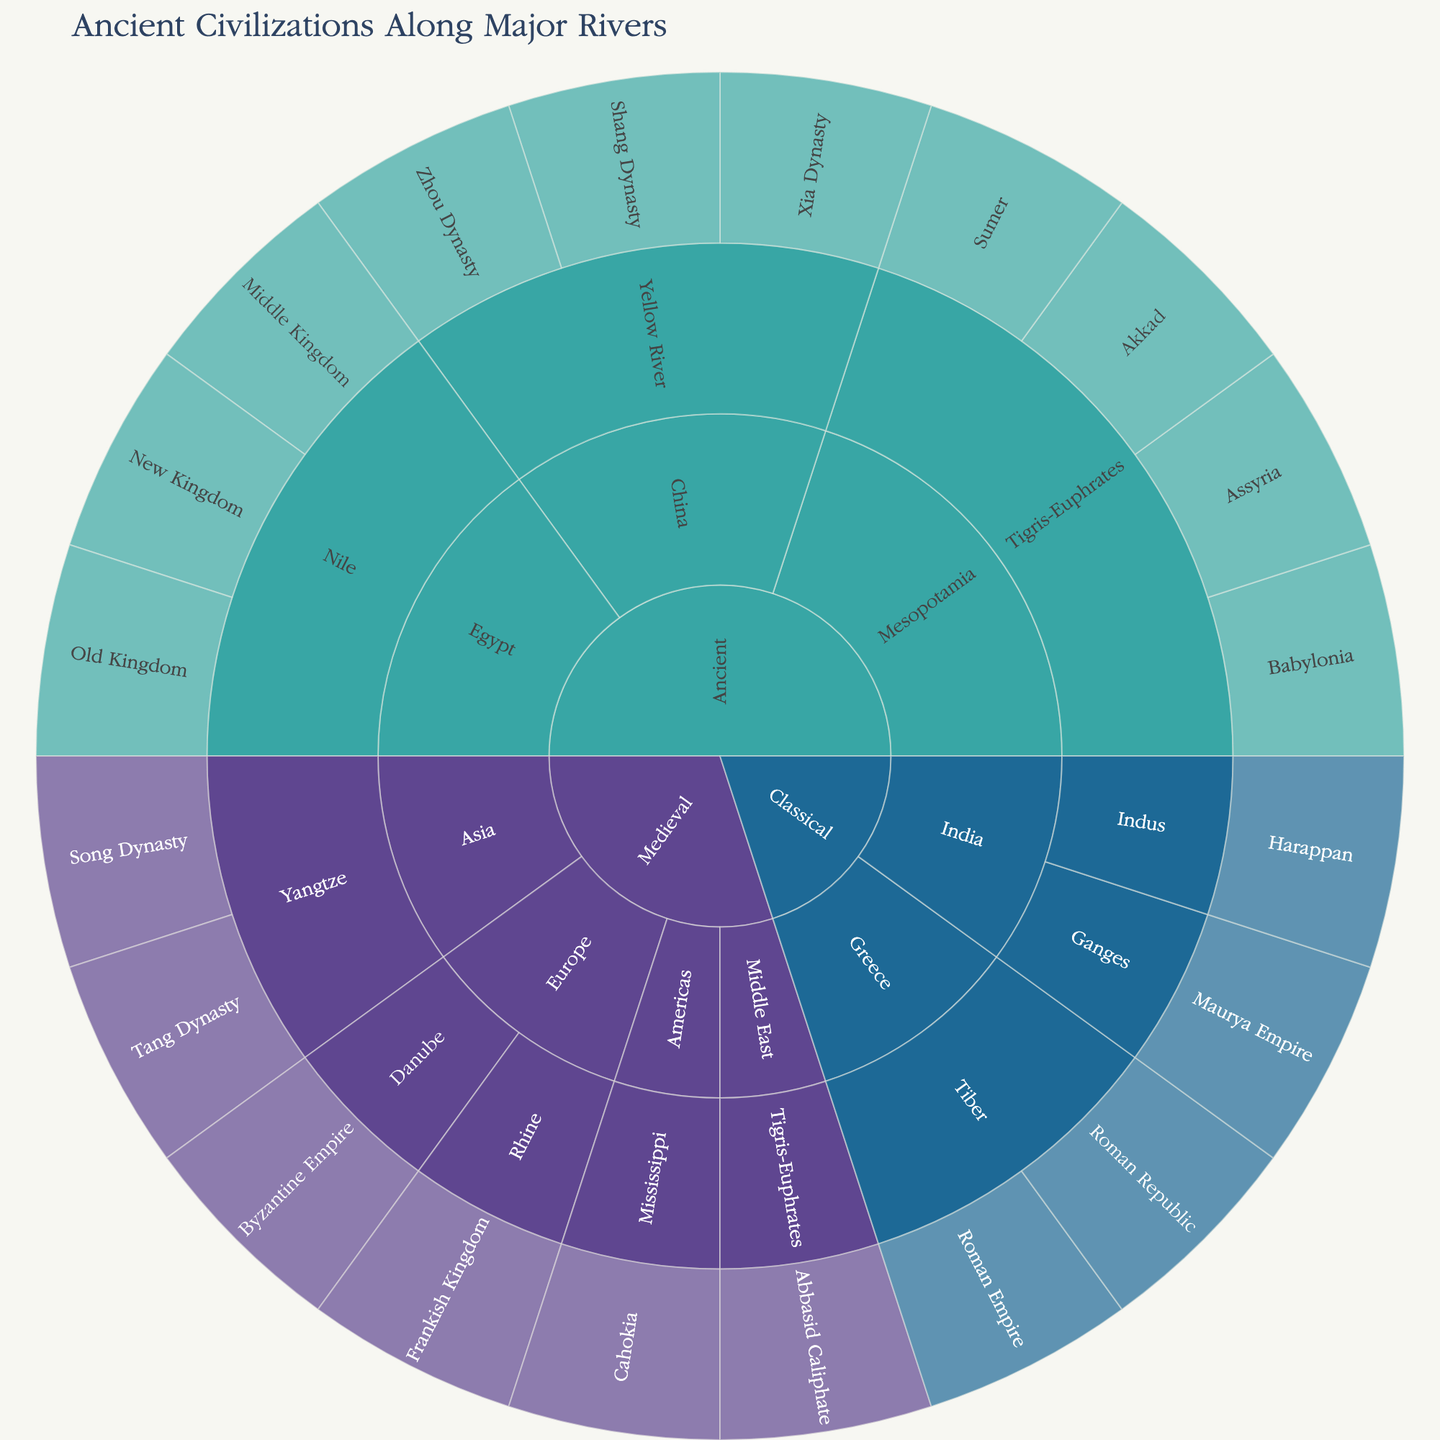What is the title of the figure? The title is usually located at the top of the figure and provides a summary of what the plot represents. In this case, it is clearly stated in the code provided.
Answer: Ancient Civilizations Along Major Rivers Which time periods are represented in the plot? Looking at the outermost ring of the plot, we can see labels that represent various time periods.
Answer: Ancient, Classical, Medieval Which river is associated with the Mesopotamian civilizations? By tracing the Mesopotamian branch in the plot, we can see which river is listed under the Mesopotamia region.
Answer: Tigris-Euphrates How many civilizations are associated with the Nile River? Navigate through the plot to the Egypt section under the Ancient time period, then count the number of civilizations listed under the Nile River.
Answer: 3 Which regions are associated with the Medieval time period? Look at the sections of the sunburst plot that are labeled as Medieval and note the names of the regions.
Answer: Europe, Middle East, Asia, Americas What is the sequence of Chinese dynasties along the Yellow River? Follow the path from the China section in the Ancient time period, then look at the sequence of dynasties listed under the Yellow River.
Answer: Xia Dynasty, Shang Dynasty, Zhou Dynasty How does the number of civilizations associated with the Tigris-Euphrates River compare between Ancient and Medieval periods? First, count the number of civilizations listed under the Tigris-Euphrates River in both the Ancient and Medieval sections of the plot. Compare these counts.
Answer: Ancient: 4, Medieval: 1 Which major river is associated with civilizations in both the Ancient and Medieval periods? Look for rivers that appear under both the Ancient and Medieval sections in the plot.
Answer: Tigris-Euphrates How many different regions are represented in the Classical period? Look at the Classical section of the plot and count how many different regions are listed under this time period.
Answer: 3 Which civilization is found along the Mississippi River in the Medieval period? Navigate to the Medieval section of the plot, find the Americas region, and then look at the civilization listed under the Mississippi River.
Answer: Cahokia 